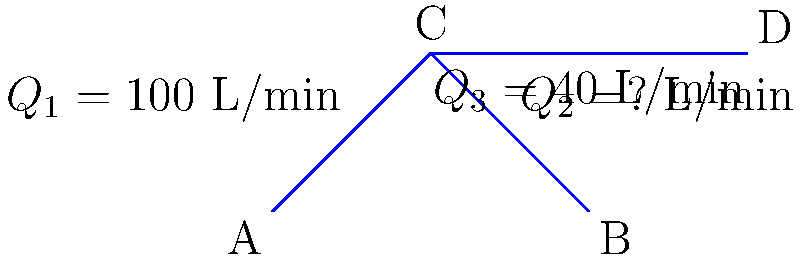In the pipe network shown, water flows from point A to points B and D. The flow rate at point A ($Q_1$) is 100 L/min, and the flow rate to point D ($Q_3$) is 40 L/min. Using the principle of conservation of mass, calculate the flow rate $Q_2$ to point B. To solve this problem, we'll use the principle of conservation of mass, which states that the total mass entering a junction must equal the total mass leaving it. In fluid mechanics, this translates to the continuity equation for incompressible flow.

Step 1: Identify the junction and the known flow rates.
- Junction C is where the flow splits.
- $Q_1 = 100$ L/min (inflow)
- $Q_3 = 40$ L/min (outflow to D)

Step 2: Apply the continuity equation at junction C.
$Q_{in} = Q_{out}$
$Q_1 = Q_2 + Q_3$

Step 3: Substitute the known values.
$100 = Q_2 + 40$

Step 4: Solve for $Q_2$.
$Q_2 = 100 - 40 = 60$ L/min

Therefore, the flow rate to point B ($Q_2$) is 60 L/min.
Answer: 60 L/min 